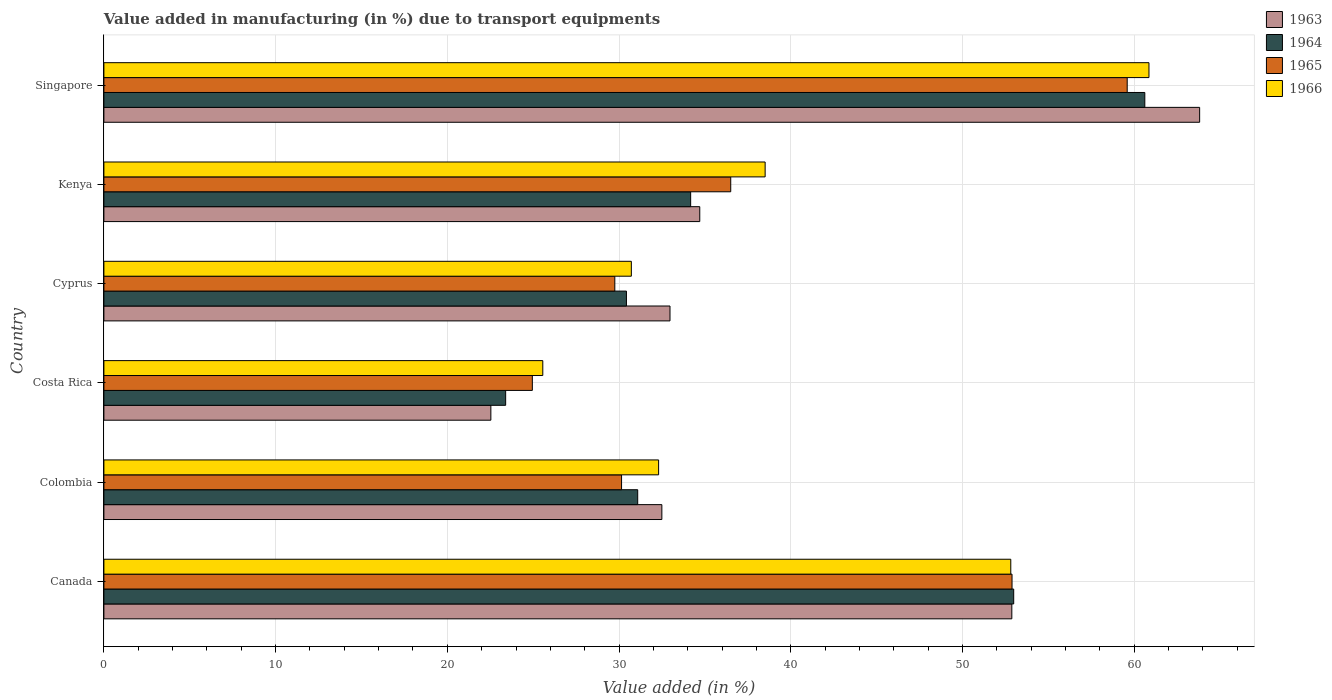How many different coloured bars are there?
Provide a succinct answer. 4. How many bars are there on the 4th tick from the bottom?
Your response must be concise. 4. What is the label of the 4th group of bars from the top?
Offer a very short reply. Costa Rica. In how many cases, is the number of bars for a given country not equal to the number of legend labels?
Your answer should be very brief. 0. What is the percentage of value added in manufacturing due to transport equipments in 1963 in Cyprus?
Your answer should be compact. 32.97. Across all countries, what is the maximum percentage of value added in manufacturing due to transport equipments in 1963?
Offer a terse response. 63.81. Across all countries, what is the minimum percentage of value added in manufacturing due to transport equipments in 1963?
Offer a very short reply. 22.53. In which country was the percentage of value added in manufacturing due to transport equipments in 1964 maximum?
Provide a short and direct response. Singapore. What is the total percentage of value added in manufacturing due to transport equipments in 1965 in the graph?
Offer a very short reply. 233.83. What is the difference between the percentage of value added in manufacturing due to transport equipments in 1963 in Cyprus and that in Kenya?
Provide a short and direct response. -1.73. What is the difference between the percentage of value added in manufacturing due to transport equipments in 1966 in Costa Rica and the percentage of value added in manufacturing due to transport equipments in 1963 in Canada?
Provide a short and direct response. -27.31. What is the average percentage of value added in manufacturing due to transport equipments in 1964 per country?
Your answer should be compact. 38.78. What is the difference between the percentage of value added in manufacturing due to transport equipments in 1963 and percentage of value added in manufacturing due to transport equipments in 1966 in Singapore?
Give a very brief answer. 2.95. What is the ratio of the percentage of value added in manufacturing due to transport equipments in 1966 in Costa Rica to that in Kenya?
Offer a very short reply. 0.66. Is the percentage of value added in manufacturing due to transport equipments in 1964 in Costa Rica less than that in Kenya?
Offer a terse response. Yes. Is the difference between the percentage of value added in manufacturing due to transport equipments in 1963 in Colombia and Cyprus greater than the difference between the percentage of value added in manufacturing due to transport equipments in 1966 in Colombia and Cyprus?
Your answer should be compact. No. What is the difference between the highest and the second highest percentage of value added in manufacturing due to transport equipments in 1965?
Provide a succinct answer. 6.71. What is the difference between the highest and the lowest percentage of value added in manufacturing due to transport equipments in 1966?
Your response must be concise. 35.3. In how many countries, is the percentage of value added in manufacturing due to transport equipments in 1966 greater than the average percentage of value added in manufacturing due to transport equipments in 1966 taken over all countries?
Keep it short and to the point. 2. Is it the case that in every country, the sum of the percentage of value added in manufacturing due to transport equipments in 1965 and percentage of value added in manufacturing due to transport equipments in 1964 is greater than the sum of percentage of value added in manufacturing due to transport equipments in 1966 and percentage of value added in manufacturing due to transport equipments in 1963?
Keep it short and to the point. No. What does the 2nd bar from the top in Singapore represents?
Give a very brief answer. 1965. What does the 3rd bar from the bottom in Colombia represents?
Give a very brief answer. 1965. How many bars are there?
Your answer should be very brief. 24. Are all the bars in the graph horizontal?
Your response must be concise. Yes. How many legend labels are there?
Keep it short and to the point. 4. What is the title of the graph?
Your answer should be very brief. Value added in manufacturing (in %) due to transport equipments. What is the label or title of the X-axis?
Provide a short and direct response. Value added (in %). What is the Value added (in %) in 1963 in Canada?
Provide a short and direct response. 52.87. What is the Value added (in %) of 1964 in Canada?
Make the answer very short. 52.98. What is the Value added (in %) of 1965 in Canada?
Offer a terse response. 52.89. What is the Value added (in %) of 1966 in Canada?
Provide a short and direct response. 52.81. What is the Value added (in %) of 1963 in Colombia?
Your answer should be compact. 32.49. What is the Value added (in %) of 1964 in Colombia?
Provide a short and direct response. 31.09. What is the Value added (in %) in 1965 in Colombia?
Ensure brevity in your answer.  30.15. What is the Value added (in %) in 1966 in Colombia?
Make the answer very short. 32.3. What is the Value added (in %) in 1963 in Costa Rica?
Your answer should be very brief. 22.53. What is the Value added (in %) of 1964 in Costa Rica?
Make the answer very short. 23.4. What is the Value added (in %) of 1965 in Costa Rica?
Keep it short and to the point. 24.95. What is the Value added (in %) in 1966 in Costa Rica?
Offer a very short reply. 25.56. What is the Value added (in %) in 1963 in Cyprus?
Offer a terse response. 32.97. What is the Value added (in %) in 1964 in Cyprus?
Ensure brevity in your answer.  30.43. What is the Value added (in %) in 1965 in Cyprus?
Offer a very short reply. 29.75. What is the Value added (in %) in 1966 in Cyprus?
Provide a short and direct response. 30.72. What is the Value added (in %) in 1963 in Kenya?
Provide a short and direct response. 34.7. What is the Value added (in %) of 1964 in Kenya?
Give a very brief answer. 34.17. What is the Value added (in %) of 1965 in Kenya?
Your answer should be compact. 36.5. What is the Value added (in %) in 1966 in Kenya?
Your answer should be very brief. 38.51. What is the Value added (in %) in 1963 in Singapore?
Provide a short and direct response. 63.81. What is the Value added (in %) of 1964 in Singapore?
Give a very brief answer. 60.62. What is the Value added (in %) of 1965 in Singapore?
Your answer should be compact. 59.59. What is the Value added (in %) of 1966 in Singapore?
Provide a short and direct response. 60.86. Across all countries, what is the maximum Value added (in %) in 1963?
Keep it short and to the point. 63.81. Across all countries, what is the maximum Value added (in %) of 1964?
Keep it short and to the point. 60.62. Across all countries, what is the maximum Value added (in %) in 1965?
Make the answer very short. 59.59. Across all countries, what is the maximum Value added (in %) in 1966?
Ensure brevity in your answer.  60.86. Across all countries, what is the minimum Value added (in %) in 1963?
Give a very brief answer. 22.53. Across all countries, what is the minimum Value added (in %) of 1964?
Keep it short and to the point. 23.4. Across all countries, what is the minimum Value added (in %) in 1965?
Keep it short and to the point. 24.95. Across all countries, what is the minimum Value added (in %) in 1966?
Your answer should be very brief. 25.56. What is the total Value added (in %) of 1963 in the graph?
Make the answer very short. 239.38. What is the total Value added (in %) in 1964 in the graph?
Offer a terse response. 232.68. What is the total Value added (in %) in 1965 in the graph?
Keep it short and to the point. 233.83. What is the total Value added (in %) in 1966 in the graph?
Your answer should be compact. 240.76. What is the difference between the Value added (in %) of 1963 in Canada and that in Colombia?
Give a very brief answer. 20.38. What is the difference between the Value added (in %) of 1964 in Canada and that in Colombia?
Your response must be concise. 21.9. What is the difference between the Value added (in %) in 1965 in Canada and that in Colombia?
Ensure brevity in your answer.  22.74. What is the difference between the Value added (in %) of 1966 in Canada and that in Colombia?
Your answer should be very brief. 20.51. What is the difference between the Value added (in %) in 1963 in Canada and that in Costa Rica?
Your answer should be compact. 30.34. What is the difference between the Value added (in %) of 1964 in Canada and that in Costa Rica?
Offer a terse response. 29.59. What is the difference between the Value added (in %) in 1965 in Canada and that in Costa Rica?
Ensure brevity in your answer.  27.93. What is the difference between the Value added (in %) in 1966 in Canada and that in Costa Rica?
Give a very brief answer. 27.25. What is the difference between the Value added (in %) in 1963 in Canada and that in Cyprus?
Make the answer very short. 19.91. What is the difference between the Value added (in %) in 1964 in Canada and that in Cyprus?
Ensure brevity in your answer.  22.55. What is the difference between the Value added (in %) of 1965 in Canada and that in Cyprus?
Your answer should be very brief. 23.13. What is the difference between the Value added (in %) in 1966 in Canada and that in Cyprus?
Give a very brief answer. 22.1. What is the difference between the Value added (in %) in 1963 in Canada and that in Kenya?
Your answer should be very brief. 18.17. What is the difference between the Value added (in %) of 1964 in Canada and that in Kenya?
Your response must be concise. 18.81. What is the difference between the Value added (in %) of 1965 in Canada and that in Kenya?
Ensure brevity in your answer.  16.38. What is the difference between the Value added (in %) of 1966 in Canada and that in Kenya?
Offer a terse response. 14.3. What is the difference between the Value added (in %) of 1963 in Canada and that in Singapore?
Provide a succinct answer. -10.94. What is the difference between the Value added (in %) in 1964 in Canada and that in Singapore?
Your response must be concise. -7.63. What is the difference between the Value added (in %) in 1965 in Canada and that in Singapore?
Offer a very short reply. -6.71. What is the difference between the Value added (in %) in 1966 in Canada and that in Singapore?
Your answer should be compact. -8.05. What is the difference between the Value added (in %) in 1963 in Colombia and that in Costa Rica?
Provide a short and direct response. 9.96. What is the difference between the Value added (in %) of 1964 in Colombia and that in Costa Rica?
Provide a succinct answer. 7.69. What is the difference between the Value added (in %) of 1965 in Colombia and that in Costa Rica?
Give a very brief answer. 5.2. What is the difference between the Value added (in %) of 1966 in Colombia and that in Costa Rica?
Provide a short and direct response. 6.74. What is the difference between the Value added (in %) of 1963 in Colombia and that in Cyprus?
Give a very brief answer. -0.47. What is the difference between the Value added (in %) of 1964 in Colombia and that in Cyprus?
Make the answer very short. 0.66. What is the difference between the Value added (in %) in 1965 in Colombia and that in Cyprus?
Make the answer very short. 0.39. What is the difference between the Value added (in %) in 1966 in Colombia and that in Cyprus?
Give a very brief answer. 1.59. What is the difference between the Value added (in %) of 1963 in Colombia and that in Kenya?
Your answer should be compact. -2.21. What is the difference between the Value added (in %) in 1964 in Colombia and that in Kenya?
Your response must be concise. -3.08. What is the difference between the Value added (in %) in 1965 in Colombia and that in Kenya?
Offer a very short reply. -6.36. What is the difference between the Value added (in %) in 1966 in Colombia and that in Kenya?
Offer a very short reply. -6.2. What is the difference between the Value added (in %) in 1963 in Colombia and that in Singapore?
Give a very brief answer. -31.32. What is the difference between the Value added (in %) in 1964 in Colombia and that in Singapore?
Give a very brief answer. -29.53. What is the difference between the Value added (in %) of 1965 in Colombia and that in Singapore?
Offer a very short reply. -29.45. What is the difference between the Value added (in %) of 1966 in Colombia and that in Singapore?
Your answer should be very brief. -28.56. What is the difference between the Value added (in %) in 1963 in Costa Rica and that in Cyprus?
Your answer should be compact. -10.43. What is the difference between the Value added (in %) in 1964 in Costa Rica and that in Cyprus?
Make the answer very short. -7.03. What is the difference between the Value added (in %) in 1965 in Costa Rica and that in Cyprus?
Offer a terse response. -4.8. What is the difference between the Value added (in %) of 1966 in Costa Rica and that in Cyprus?
Your response must be concise. -5.16. What is the difference between the Value added (in %) in 1963 in Costa Rica and that in Kenya?
Give a very brief answer. -12.17. What is the difference between the Value added (in %) in 1964 in Costa Rica and that in Kenya?
Ensure brevity in your answer.  -10.77. What is the difference between the Value added (in %) of 1965 in Costa Rica and that in Kenya?
Ensure brevity in your answer.  -11.55. What is the difference between the Value added (in %) of 1966 in Costa Rica and that in Kenya?
Your response must be concise. -12.95. What is the difference between the Value added (in %) in 1963 in Costa Rica and that in Singapore?
Offer a terse response. -41.28. What is the difference between the Value added (in %) in 1964 in Costa Rica and that in Singapore?
Offer a very short reply. -37.22. What is the difference between the Value added (in %) in 1965 in Costa Rica and that in Singapore?
Offer a very short reply. -34.64. What is the difference between the Value added (in %) of 1966 in Costa Rica and that in Singapore?
Provide a succinct answer. -35.3. What is the difference between the Value added (in %) of 1963 in Cyprus and that in Kenya?
Offer a terse response. -1.73. What is the difference between the Value added (in %) in 1964 in Cyprus and that in Kenya?
Your answer should be very brief. -3.74. What is the difference between the Value added (in %) in 1965 in Cyprus and that in Kenya?
Make the answer very short. -6.75. What is the difference between the Value added (in %) in 1966 in Cyprus and that in Kenya?
Offer a terse response. -7.79. What is the difference between the Value added (in %) of 1963 in Cyprus and that in Singapore?
Provide a succinct answer. -30.84. What is the difference between the Value added (in %) in 1964 in Cyprus and that in Singapore?
Keep it short and to the point. -30.19. What is the difference between the Value added (in %) of 1965 in Cyprus and that in Singapore?
Give a very brief answer. -29.84. What is the difference between the Value added (in %) in 1966 in Cyprus and that in Singapore?
Ensure brevity in your answer.  -30.14. What is the difference between the Value added (in %) of 1963 in Kenya and that in Singapore?
Keep it short and to the point. -29.11. What is the difference between the Value added (in %) of 1964 in Kenya and that in Singapore?
Your answer should be very brief. -26.45. What is the difference between the Value added (in %) in 1965 in Kenya and that in Singapore?
Make the answer very short. -23.09. What is the difference between the Value added (in %) of 1966 in Kenya and that in Singapore?
Ensure brevity in your answer.  -22.35. What is the difference between the Value added (in %) of 1963 in Canada and the Value added (in %) of 1964 in Colombia?
Ensure brevity in your answer.  21.79. What is the difference between the Value added (in %) in 1963 in Canada and the Value added (in %) in 1965 in Colombia?
Your answer should be compact. 22.73. What is the difference between the Value added (in %) of 1963 in Canada and the Value added (in %) of 1966 in Colombia?
Your response must be concise. 20.57. What is the difference between the Value added (in %) in 1964 in Canada and the Value added (in %) in 1965 in Colombia?
Make the answer very short. 22.84. What is the difference between the Value added (in %) in 1964 in Canada and the Value added (in %) in 1966 in Colombia?
Your answer should be very brief. 20.68. What is the difference between the Value added (in %) of 1965 in Canada and the Value added (in %) of 1966 in Colombia?
Provide a succinct answer. 20.58. What is the difference between the Value added (in %) in 1963 in Canada and the Value added (in %) in 1964 in Costa Rica?
Your answer should be very brief. 29.48. What is the difference between the Value added (in %) of 1963 in Canada and the Value added (in %) of 1965 in Costa Rica?
Provide a short and direct response. 27.92. What is the difference between the Value added (in %) in 1963 in Canada and the Value added (in %) in 1966 in Costa Rica?
Provide a succinct answer. 27.31. What is the difference between the Value added (in %) in 1964 in Canada and the Value added (in %) in 1965 in Costa Rica?
Give a very brief answer. 28.03. What is the difference between the Value added (in %) of 1964 in Canada and the Value added (in %) of 1966 in Costa Rica?
Provide a succinct answer. 27.42. What is the difference between the Value added (in %) of 1965 in Canada and the Value added (in %) of 1966 in Costa Rica?
Your answer should be compact. 27.33. What is the difference between the Value added (in %) in 1963 in Canada and the Value added (in %) in 1964 in Cyprus?
Keep it short and to the point. 22.44. What is the difference between the Value added (in %) in 1963 in Canada and the Value added (in %) in 1965 in Cyprus?
Your response must be concise. 23.12. What is the difference between the Value added (in %) in 1963 in Canada and the Value added (in %) in 1966 in Cyprus?
Provide a short and direct response. 22.16. What is the difference between the Value added (in %) of 1964 in Canada and the Value added (in %) of 1965 in Cyprus?
Your answer should be very brief. 23.23. What is the difference between the Value added (in %) of 1964 in Canada and the Value added (in %) of 1966 in Cyprus?
Give a very brief answer. 22.27. What is the difference between the Value added (in %) in 1965 in Canada and the Value added (in %) in 1966 in Cyprus?
Your response must be concise. 22.17. What is the difference between the Value added (in %) of 1963 in Canada and the Value added (in %) of 1964 in Kenya?
Provide a succinct answer. 18.7. What is the difference between the Value added (in %) in 1963 in Canada and the Value added (in %) in 1965 in Kenya?
Provide a succinct answer. 16.37. What is the difference between the Value added (in %) of 1963 in Canada and the Value added (in %) of 1966 in Kenya?
Provide a succinct answer. 14.37. What is the difference between the Value added (in %) in 1964 in Canada and the Value added (in %) in 1965 in Kenya?
Your response must be concise. 16.48. What is the difference between the Value added (in %) of 1964 in Canada and the Value added (in %) of 1966 in Kenya?
Your answer should be very brief. 14.47. What is the difference between the Value added (in %) in 1965 in Canada and the Value added (in %) in 1966 in Kenya?
Your response must be concise. 14.38. What is the difference between the Value added (in %) in 1963 in Canada and the Value added (in %) in 1964 in Singapore?
Make the answer very short. -7.74. What is the difference between the Value added (in %) in 1963 in Canada and the Value added (in %) in 1965 in Singapore?
Offer a very short reply. -6.72. What is the difference between the Value added (in %) of 1963 in Canada and the Value added (in %) of 1966 in Singapore?
Ensure brevity in your answer.  -7.99. What is the difference between the Value added (in %) in 1964 in Canada and the Value added (in %) in 1965 in Singapore?
Your answer should be very brief. -6.61. What is the difference between the Value added (in %) in 1964 in Canada and the Value added (in %) in 1966 in Singapore?
Your answer should be very brief. -7.88. What is the difference between the Value added (in %) in 1965 in Canada and the Value added (in %) in 1966 in Singapore?
Keep it short and to the point. -7.97. What is the difference between the Value added (in %) of 1963 in Colombia and the Value added (in %) of 1964 in Costa Rica?
Your answer should be compact. 9.1. What is the difference between the Value added (in %) in 1963 in Colombia and the Value added (in %) in 1965 in Costa Rica?
Provide a succinct answer. 7.54. What is the difference between the Value added (in %) of 1963 in Colombia and the Value added (in %) of 1966 in Costa Rica?
Provide a short and direct response. 6.93. What is the difference between the Value added (in %) of 1964 in Colombia and the Value added (in %) of 1965 in Costa Rica?
Offer a terse response. 6.14. What is the difference between the Value added (in %) of 1964 in Colombia and the Value added (in %) of 1966 in Costa Rica?
Provide a succinct answer. 5.53. What is the difference between the Value added (in %) of 1965 in Colombia and the Value added (in %) of 1966 in Costa Rica?
Keep it short and to the point. 4.59. What is the difference between the Value added (in %) of 1963 in Colombia and the Value added (in %) of 1964 in Cyprus?
Your answer should be very brief. 2.06. What is the difference between the Value added (in %) of 1963 in Colombia and the Value added (in %) of 1965 in Cyprus?
Ensure brevity in your answer.  2.74. What is the difference between the Value added (in %) of 1963 in Colombia and the Value added (in %) of 1966 in Cyprus?
Make the answer very short. 1.78. What is the difference between the Value added (in %) of 1964 in Colombia and the Value added (in %) of 1965 in Cyprus?
Offer a terse response. 1.33. What is the difference between the Value added (in %) of 1964 in Colombia and the Value added (in %) of 1966 in Cyprus?
Provide a succinct answer. 0.37. What is the difference between the Value added (in %) of 1965 in Colombia and the Value added (in %) of 1966 in Cyprus?
Offer a terse response. -0.57. What is the difference between the Value added (in %) in 1963 in Colombia and the Value added (in %) in 1964 in Kenya?
Provide a succinct answer. -1.68. What is the difference between the Value added (in %) of 1963 in Colombia and the Value added (in %) of 1965 in Kenya?
Ensure brevity in your answer.  -4.01. What is the difference between the Value added (in %) in 1963 in Colombia and the Value added (in %) in 1966 in Kenya?
Your response must be concise. -6.01. What is the difference between the Value added (in %) in 1964 in Colombia and the Value added (in %) in 1965 in Kenya?
Make the answer very short. -5.42. What is the difference between the Value added (in %) in 1964 in Colombia and the Value added (in %) in 1966 in Kenya?
Your answer should be very brief. -7.42. What is the difference between the Value added (in %) of 1965 in Colombia and the Value added (in %) of 1966 in Kenya?
Provide a short and direct response. -8.36. What is the difference between the Value added (in %) of 1963 in Colombia and the Value added (in %) of 1964 in Singapore?
Your response must be concise. -28.12. What is the difference between the Value added (in %) of 1963 in Colombia and the Value added (in %) of 1965 in Singapore?
Provide a short and direct response. -27.1. What is the difference between the Value added (in %) of 1963 in Colombia and the Value added (in %) of 1966 in Singapore?
Keep it short and to the point. -28.37. What is the difference between the Value added (in %) of 1964 in Colombia and the Value added (in %) of 1965 in Singapore?
Your response must be concise. -28.51. What is the difference between the Value added (in %) in 1964 in Colombia and the Value added (in %) in 1966 in Singapore?
Keep it short and to the point. -29.77. What is the difference between the Value added (in %) in 1965 in Colombia and the Value added (in %) in 1966 in Singapore?
Your response must be concise. -30.71. What is the difference between the Value added (in %) in 1963 in Costa Rica and the Value added (in %) in 1964 in Cyprus?
Keep it short and to the point. -7.9. What is the difference between the Value added (in %) of 1963 in Costa Rica and the Value added (in %) of 1965 in Cyprus?
Keep it short and to the point. -7.22. What is the difference between the Value added (in %) in 1963 in Costa Rica and the Value added (in %) in 1966 in Cyprus?
Offer a terse response. -8.18. What is the difference between the Value added (in %) of 1964 in Costa Rica and the Value added (in %) of 1965 in Cyprus?
Your answer should be compact. -6.36. What is the difference between the Value added (in %) in 1964 in Costa Rica and the Value added (in %) in 1966 in Cyprus?
Your answer should be very brief. -7.32. What is the difference between the Value added (in %) of 1965 in Costa Rica and the Value added (in %) of 1966 in Cyprus?
Ensure brevity in your answer.  -5.77. What is the difference between the Value added (in %) of 1963 in Costa Rica and the Value added (in %) of 1964 in Kenya?
Ensure brevity in your answer.  -11.64. What is the difference between the Value added (in %) in 1963 in Costa Rica and the Value added (in %) in 1965 in Kenya?
Offer a very short reply. -13.97. What is the difference between the Value added (in %) of 1963 in Costa Rica and the Value added (in %) of 1966 in Kenya?
Your answer should be compact. -15.97. What is the difference between the Value added (in %) of 1964 in Costa Rica and the Value added (in %) of 1965 in Kenya?
Your answer should be very brief. -13.11. What is the difference between the Value added (in %) of 1964 in Costa Rica and the Value added (in %) of 1966 in Kenya?
Ensure brevity in your answer.  -15.11. What is the difference between the Value added (in %) in 1965 in Costa Rica and the Value added (in %) in 1966 in Kenya?
Keep it short and to the point. -13.56. What is the difference between the Value added (in %) of 1963 in Costa Rica and the Value added (in %) of 1964 in Singapore?
Provide a succinct answer. -38.08. What is the difference between the Value added (in %) of 1963 in Costa Rica and the Value added (in %) of 1965 in Singapore?
Keep it short and to the point. -37.06. What is the difference between the Value added (in %) of 1963 in Costa Rica and the Value added (in %) of 1966 in Singapore?
Your response must be concise. -38.33. What is the difference between the Value added (in %) in 1964 in Costa Rica and the Value added (in %) in 1965 in Singapore?
Provide a short and direct response. -36.19. What is the difference between the Value added (in %) in 1964 in Costa Rica and the Value added (in %) in 1966 in Singapore?
Ensure brevity in your answer.  -37.46. What is the difference between the Value added (in %) in 1965 in Costa Rica and the Value added (in %) in 1966 in Singapore?
Offer a terse response. -35.91. What is the difference between the Value added (in %) of 1963 in Cyprus and the Value added (in %) of 1964 in Kenya?
Give a very brief answer. -1.2. What is the difference between the Value added (in %) in 1963 in Cyprus and the Value added (in %) in 1965 in Kenya?
Offer a terse response. -3.54. What is the difference between the Value added (in %) of 1963 in Cyprus and the Value added (in %) of 1966 in Kenya?
Provide a succinct answer. -5.54. What is the difference between the Value added (in %) of 1964 in Cyprus and the Value added (in %) of 1965 in Kenya?
Provide a short and direct response. -6.07. What is the difference between the Value added (in %) in 1964 in Cyprus and the Value added (in %) in 1966 in Kenya?
Provide a succinct answer. -8.08. What is the difference between the Value added (in %) of 1965 in Cyprus and the Value added (in %) of 1966 in Kenya?
Provide a succinct answer. -8.75. What is the difference between the Value added (in %) of 1963 in Cyprus and the Value added (in %) of 1964 in Singapore?
Give a very brief answer. -27.65. What is the difference between the Value added (in %) of 1963 in Cyprus and the Value added (in %) of 1965 in Singapore?
Offer a terse response. -26.62. What is the difference between the Value added (in %) in 1963 in Cyprus and the Value added (in %) in 1966 in Singapore?
Offer a terse response. -27.89. What is the difference between the Value added (in %) of 1964 in Cyprus and the Value added (in %) of 1965 in Singapore?
Offer a terse response. -29.16. What is the difference between the Value added (in %) in 1964 in Cyprus and the Value added (in %) in 1966 in Singapore?
Your answer should be very brief. -30.43. What is the difference between the Value added (in %) in 1965 in Cyprus and the Value added (in %) in 1966 in Singapore?
Your response must be concise. -31.11. What is the difference between the Value added (in %) of 1963 in Kenya and the Value added (in %) of 1964 in Singapore?
Offer a very short reply. -25.92. What is the difference between the Value added (in %) of 1963 in Kenya and the Value added (in %) of 1965 in Singapore?
Offer a very short reply. -24.89. What is the difference between the Value added (in %) of 1963 in Kenya and the Value added (in %) of 1966 in Singapore?
Keep it short and to the point. -26.16. What is the difference between the Value added (in %) in 1964 in Kenya and the Value added (in %) in 1965 in Singapore?
Give a very brief answer. -25.42. What is the difference between the Value added (in %) in 1964 in Kenya and the Value added (in %) in 1966 in Singapore?
Ensure brevity in your answer.  -26.69. What is the difference between the Value added (in %) of 1965 in Kenya and the Value added (in %) of 1966 in Singapore?
Offer a very short reply. -24.36. What is the average Value added (in %) in 1963 per country?
Your answer should be very brief. 39.9. What is the average Value added (in %) in 1964 per country?
Provide a short and direct response. 38.78. What is the average Value added (in %) of 1965 per country?
Offer a very short reply. 38.97. What is the average Value added (in %) of 1966 per country?
Make the answer very short. 40.13. What is the difference between the Value added (in %) in 1963 and Value added (in %) in 1964 in Canada?
Offer a very short reply. -0.11. What is the difference between the Value added (in %) in 1963 and Value added (in %) in 1965 in Canada?
Provide a succinct answer. -0.01. What is the difference between the Value added (in %) in 1963 and Value added (in %) in 1966 in Canada?
Your answer should be very brief. 0.06. What is the difference between the Value added (in %) of 1964 and Value added (in %) of 1965 in Canada?
Your answer should be very brief. 0.1. What is the difference between the Value added (in %) of 1964 and Value added (in %) of 1966 in Canada?
Your answer should be very brief. 0.17. What is the difference between the Value added (in %) of 1965 and Value added (in %) of 1966 in Canada?
Your response must be concise. 0.07. What is the difference between the Value added (in %) in 1963 and Value added (in %) in 1964 in Colombia?
Give a very brief answer. 1.41. What is the difference between the Value added (in %) in 1963 and Value added (in %) in 1965 in Colombia?
Make the answer very short. 2.35. What is the difference between the Value added (in %) in 1963 and Value added (in %) in 1966 in Colombia?
Your answer should be compact. 0.19. What is the difference between the Value added (in %) in 1964 and Value added (in %) in 1965 in Colombia?
Your answer should be compact. 0.94. What is the difference between the Value added (in %) of 1964 and Value added (in %) of 1966 in Colombia?
Your answer should be compact. -1.22. What is the difference between the Value added (in %) of 1965 and Value added (in %) of 1966 in Colombia?
Ensure brevity in your answer.  -2.16. What is the difference between the Value added (in %) in 1963 and Value added (in %) in 1964 in Costa Rica?
Keep it short and to the point. -0.86. What is the difference between the Value added (in %) of 1963 and Value added (in %) of 1965 in Costa Rica?
Offer a terse response. -2.42. What is the difference between the Value added (in %) in 1963 and Value added (in %) in 1966 in Costa Rica?
Your answer should be compact. -3.03. What is the difference between the Value added (in %) of 1964 and Value added (in %) of 1965 in Costa Rica?
Ensure brevity in your answer.  -1.55. What is the difference between the Value added (in %) of 1964 and Value added (in %) of 1966 in Costa Rica?
Provide a succinct answer. -2.16. What is the difference between the Value added (in %) of 1965 and Value added (in %) of 1966 in Costa Rica?
Make the answer very short. -0.61. What is the difference between the Value added (in %) of 1963 and Value added (in %) of 1964 in Cyprus?
Offer a terse response. 2.54. What is the difference between the Value added (in %) of 1963 and Value added (in %) of 1965 in Cyprus?
Keep it short and to the point. 3.21. What is the difference between the Value added (in %) in 1963 and Value added (in %) in 1966 in Cyprus?
Make the answer very short. 2.25. What is the difference between the Value added (in %) in 1964 and Value added (in %) in 1965 in Cyprus?
Your response must be concise. 0.68. What is the difference between the Value added (in %) of 1964 and Value added (in %) of 1966 in Cyprus?
Keep it short and to the point. -0.29. What is the difference between the Value added (in %) in 1965 and Value added (in %) in 1966 in Cyprus?
Provide a succinct answer. -0.96. What is the difference between the Value added (in %) of 1963 and Value added (in %) of 1964 in Kenya?
Provide a short and direct response. 0.53. What is the difference between the Value added (in %) in 1963 and Value added (in %) in 1965 in Kenya?
Your answer should be very brief. -1.8. What is the difference between the Value added (in %) of 1963 and Value added (in %) of 1966 in Kenya?
Provide a succinct answer. -3.81. What is the difference between the Value added (in %) in 1964 and Value added (in %) in 1965 in Kenya?
Make the answer very short. -2.33. What is the difference between the Value added (in %) in 1964 and Value added (in %) in 1966 in Kenya?
Keep it short and to the point. -4.34. What is the difference between the Value added (in %) in 1965 and Value added (in %) in 1966 in Kenya?
Your answer should be very brief. -2. What is the difference between the Value added (in %) of 1963 and Value added (in %) of 1964 in Singapore?
Give a very brief answer. 3.19. What is the difference between the Value added (in %) of 1963 and Value added (in %) of 1965 in Singapore?
Provide a short and direct response. 4.22. What is the difference between the Value added (in %) in 1963 and Value added (in %) in 1966 in Singapore?
Ensure brevity in your answer.  2.95. What is the difference between the Value added (in %) of 1964 and Value added (in %) of 1965 in Singapore?
Your response must be concise. 1.03. What is the difference between the Value added (in %) of 1964 and Value added (in %) of 1966 in Singapore?
Offer a terse response. -0.24. What is the difference between the Value added (in %) of 1965 and Value added (in %) of 1966 in Singapore?
Give a very brief answer. -1.27. What is the ratio of the Value added (in %) in 1963 in Canada to that in Colombia?
Your response must be concise. 1.63. What is the ratio of the Value added (in %) in 1964 in Canada to that in Colombia?
Provide a succinct answer. 1.7. What is the ratio of the Value added (in %) in 1965 in Canada to that in Colombia?
Your response must be concise. 1.75. What is the ratio of the Value added (in %) of 1966 in Canada to that in Colombia?
Offer a terse response. 1.63. What is the ratio of the Value added (in %) of 1963 in Canada to that in Costa Rica?
Your answer should be very brief. 2.35. What is the ratio of the Value added (in %) of 1964 in Canada to that in Costa Rica?
Give a very brief answer. 2.26. What is the ratio of the Value added (in %) in 1965 in Canada to that in Costa Rica?
Provide a succinct answer. 2.12. What is the ratio of the Value added (in %) of 1966 in Canada to that in Costa Rica?
Provide a short and direct response. 2.07. What is the ratio of the Value added (in %) of 1963 in Canada to that in Cyprus?
Offer a very short reply. 1.6. What is the ratio of the Value added (in %) in 1964 in Canada to that in Cyprus?
Offer a very short reply. 1.74. What is the ratio of the Value added (in %) of 1965 in Canada to that in Cyprus?
Give a very brief answer. 1.78. What is the ratio of the Value added (in %) of 1966 in Canada to that in Cyprus?
Offer a very short reply. 1.72. What is the ratio of the Value added (in %) in 1963 in Canada to that in Kenya?
Ensure brevity in your answer.  1.52. What is the ratio of the Value added (in %) of 1964 in Canada to that in Kenya?
Your answer should be very brief. 1.55. What is the ratio of the Value added (in %) in 1965 in Canada to that in Kenya?
Provide a succinct answer. 1.45. What is the ratio of the Value added (in %) of 1966 in Canada to that in Kenya?
Your answer should be very brief. 1.37. What is the ratio of the Value added (in %) of 1963 in Canada to that in Singapore?
Offer a terse response. 0.83. What is the ratio of the Value added (in %) of 1964 in Canada to that in Singapore?
Give a very brief answer. 0.87. What is the ratio of the Value added (in %) of 1965 in Canada to that in Singapore?
Offer a very short reply. 0.89. What is the ratio of the Value added (in %) in 1966 in Canada to that in Singapore?
Your answer should be compact. 0.87. What is the ratio of the Value added (in %) in 1963 in Colombia to that in Costa Rica?
Provide a succinct answer. 1.44. What is the ratio of the Value added (in %) in 1964 in Colombia to that in Costa Rica?
Offer a terse response. 1.33. What is the ratio of the Value added (in %) of 1965 in Colombia to that in Costa Rica?
Make the answer very short. 1.21. What is the ratio of the Value added (in %) of 1966 in Colombia to that in Costa Rica?
Your response must be concise. 1.26. What is the ratio of the Value added (in %) of 1963 in Colombia to that in Cyprus?
Keep it short and to the point. 0.99. What is the ratio of the Value added (in %) of 1964 in Colombia to that in Cyprus?
Offer a very short reply. 1.02. What is the ratio of the Value added (in %) in 1965 in Colombia to that in Cyprus?
Make the answer very short. 1.01. What is the ratio of the Value added (in %) in 1966 in Colombia to that in Cyprus?
Your response must be concise. 1.05. What is the ratio of the Value added (in %) of 1963 in Colombia to that in Kenya?
Keep it short and to the point. 0.94. What is the ratio of the Value added (in %) in 1964 in Colombia to that in Kenya?
Provide a short and direct response. 0.91. What is the ratio of the Value added (in %) of 1965 in Colombia to that in Kenya?
Your response must be concise. 0.83. What is the ratio of the Value added (in %) of 1966 in Colombia to that in Kenya?
Give a very brief answer. 0.84. What is the ratio of the Value added (in %) in 1963 in Colombia to that in Singapore?
Keep it short and to the point. 0.51. What is the ratio of the Value added (in %) of 1964 in Colombia to that in Singapore?
Offer a terse response. 0.51. What is the ratio of the Value added (in %) of 1965 in Colombia to that in Singapore?
Your answer should be compact. 0.51. What is the ratio of the Value added (in %) in 1966 in Colombia to that in Singapore?
Give a very brief answer. 0.53. What is the ratio of the Value added (in %) in 1963 in Costa Rica to that in Cyprus?
Your response must be concise. 0.68. What is the ratio of the Value added (in %) in 1964 in Costa Rica to that in Cyprus?
Provide a succinct answer. 0.77. What is the ratio of the Value added (in %) of 1965 in Costa Rica to that in Cyprus?
Offer a terse response. 0.84. What is the ratio of the Value added (in %) of 1966 in Costa Rica to that in Cyprus?
Offer a very short reply. 0.83. What is the ratio of the Value added (in %) in 1963 in Costa Rica to that in Kenya?
Your answer should be very brief. 0.65. What is the ratio of the Value added (in %) of 1964 in Costa Rica to that in Kenya?
Offer a terse response. 0.68. What is the ratio of the Value added (in %) of 1965 in Costa Rica to that in Kenya?
Give a very brief answer. 0.68. What is the ratio of the Value added (in %) in 1966 in Costa Rica to that in Kenya?
Offer a terse response. 0.66. What is the ratio of the Value added (in %) of 1963 in Costa Rica to that in Singapore?
Give a very brief answer. 0.35. What is the ratio of the Value added (in %) of 1964 in Costa Rica to that in Singapore?
Make the answer very short. 0.39. What is the ratio of the Value added (in %) in 1965 in Costa Rica to that in Singapore?
Provide a succinct answer. 0.42. What is the ratio of the Value added (in %) of 1966 in Costa Rica to that in Singapore?
Your answer should be very brief. 0.42. What is the ratio of the Value added (in %) of 1963 in Cyprus to that in Kenya?
Keep it short and to the point. 0.95. What is the ratio of the Value added (in %) in 1964 in Cyprus to that in Kenya?
Ensure brevity in your answer.  0.89. What is the ratio of the Value added (in %) in 1965 in Cyprus to that in Kenya?
Ensure brevity in your answer.  0.82. What is the ratio of the Value added (in %) of 1966 in Cyprus to that in Kenya?
Offer a very short reply. 0.8. What is the ratio of the Value added (in %) of 1963 in Cyprus to that in Singapore?
Provide a succinct answer. 0.52. What is the ratio of the Value added (in %) in 1964 in Cyprus to that in Singapore?
Give a very brief answer. 0.5. What is the ratio of the Value added (in %) in 1965 in Cyprus to that in Singapore?
Offer a terse response. 0.5. What is the ratio of the Value added (in %) in 1966 in Cyprus to that in Singapore?
Keep it short and to the point. 0.5. What is the ratio of the Value added (in %) of 1963 in Kenya to that in Singapore?
Your answer should be very brief. 0.54. What is the ratio of the Value added (in %) of 1964 in Kenya to that in Singapore?
Provide a short and direct response. 0.56. What is the ratio of the Value added (in %) of 1965 in Kenya to that in Singapore?
Offer a very short reply. 0.61. What is the ratio of the Value added (in %) in 1966 in Kenya to that in Singapore?
Offer a very short reply. 0.63. What is the difference between the highest and the second highest Value added (in %) in 1963?
Make the answer very short. 10.94. What is the difference between the highest and the second highest Value added (in %) in 1964?
Offer a very short reply. 7.63. What is the difference between the highest and the second highest Value added (in %) in 1965?
Offer a very short reply. 6.71. What is the difference between the highest and the second highest Value added (in %) in 1966?
Offer a terse response. 8.05. What is the difference between the highest and the lowest Value added (in %) in 1963?
Give a very brief answer. 41.28. What is the difference between the highest and the lowest Value added (in %) of 1964?
Your answer should be very brief. 37.22. What is the difference between the highest and the lowest Value added (in %) in 1965?
Offer a very short reply. 34.64. What is the difference between the highest and the lowest Value added (in %) in 1966?
Your answer should be compact. 35.3. 